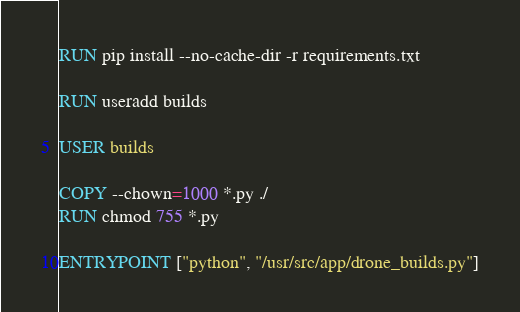Convert code to text. <code><loc_0><loc_0><loc_500><loc_500><_Dockerfile_>RUN pip install --no-cache-dir -r requirements.txt

RUN useradd builds

USER builds

COPY --chown=1000 *.py ./
RUN chmod 755 *.py

ENTRYPOINT ["python", "/usr/src/app/drone_builds.py"]
</code> 